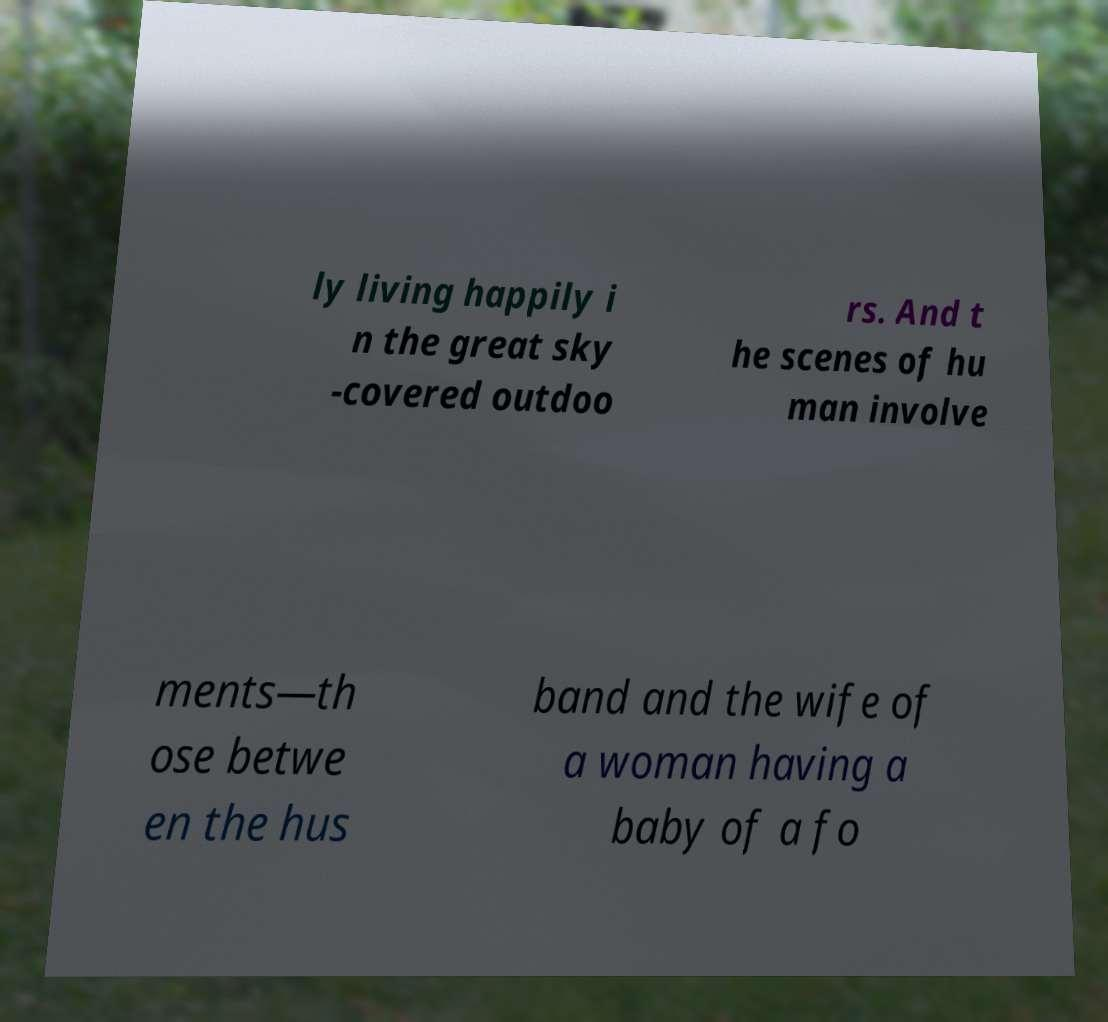Could you assist in decoding the text presented in this image and type it out clearly? ly living happily i n the great sky -covered outdoo rs. And t he scenes of hu man involve ments—th ose betwe en the hus band and the wife of a woman having a baby of a fo 